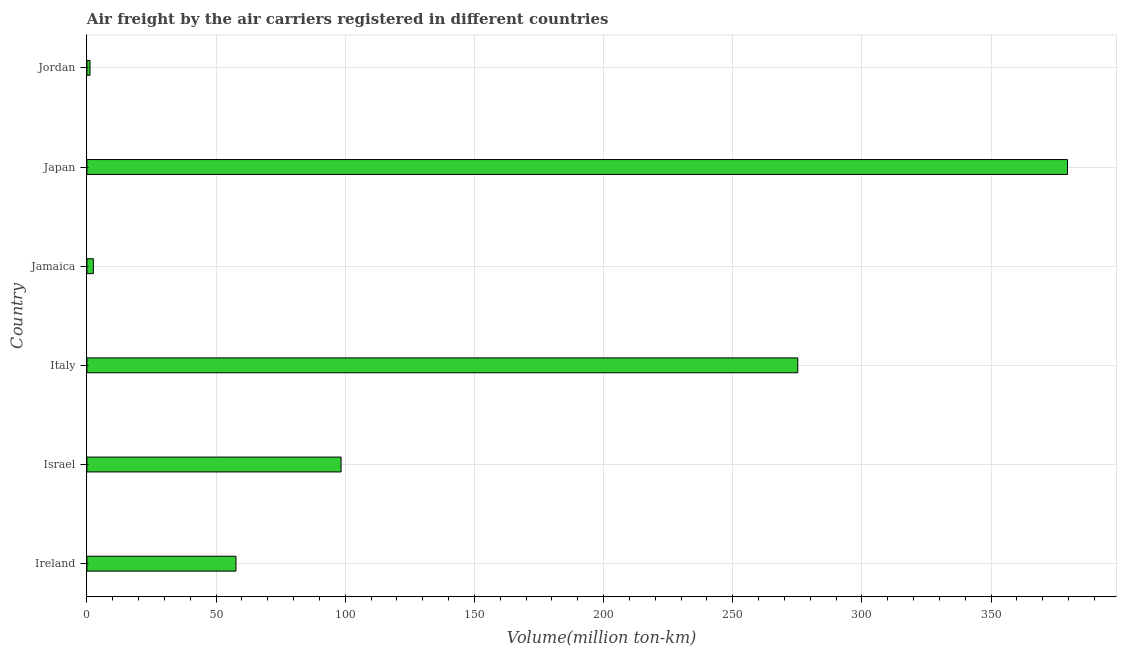Does the graph contain any zero values?
Provide a short and direct response. No. What is the title of the graph?
Ensure brevity in your answer.  Air freight by the air carriers registered in different countries. What is the label or title of the X-axis?
Provide a succinct answer. Volume(million ton-km). What is the air freight in Japan?
Offer a terse response. 379.6. Across all countries, what is the maximum air freight?
Give a very brief answer. 379.6. Across all countries, what is the minimum air freight?
Your answer should be compact. 1.2. In which country was the air freight maximum?
Your response must be concise. Japan. In which country was the air freight minimum?
Ensure brevity in your answer.  Jordan. What is the sum of the air freight?
Keep it short and to the point. 814.6. What is the difference between the air freight in Israel and Jordan?
Your answer should be compact. 97.2. What is the average air freight per country?
Your answer should be very brief. 135.77. What is the median air freight?
Give a very brief answer. 78.05. In how many countries, is the air freight greater than 80 million ton-km?
Offer a terse response. 3. What is the ratio of the air freight in Ireland to that in Israel?
Provide a short and direct response. 0.59. Is the air freight in Italy less than that in Jordan?
Give a very brief answer. No. What is the difference between the highest and the second highest air freight?
Provide a succinct answer. 104.4. What is the difference between the highest and the lowest air freight?
Your response must be concise. 378.4. In how many countries, is the air freight greater than the average air freight taken over all countries?
Your answer should be very brief. 2. How many countries are there in the graph?
Keep it short and to the point. 6. What is the difference between two consecutive major ticks on the X-axis?
Give a very brief answer. 50. What is the Volume(million ton-km) in Ireland?
Offer a very short reply. 57.7. What is the Volume(million ton-km) of Israel?
Your response must be concise. 98.4. What is the Volume(million ton-km) in Italy?
Provide a short and direct response. 275.2. What is the Volume(million ton-km) of Jamaica?
Keep it short and to the point. 2.5. What is the Volume(million ton-km) of Japan?
Your answer should be compact. 379.6. What is the Volume(million ton-km) in Jordan?
Provide a succinct answer. 1.2. What is the difference between the Volume(million ton-km) in Ireland and Israel?
Provide a succinct answer. -40.7. What is the difference between the Volume(million ton-km) in Ireland and Italy?
Offer a terse response. -217.5. What is the difference between the Volume(million ton-km) in Ireland and Jamaica?
Keep it short and to the point. 55.2. What is the difference between the Volume(million ton-km) in Ireland and Japan?
Offer a very short reply. -321.9. What is the difference between the Volume(million ton-km) in Ireland and Jordan?
Your answer should be very brief. 56.5. What is the difference between the Volume(million ton-km) in Israel and Italy?
Your answer should be compact. -176.8. What is the difference between the Volume(million ton-km) in Israel and Jamaica?
Offer a terse response. 95.9. What is the difference between the Volume(million ton-km) in Israel and Japan?
Provide a short and direct response. -281.2. What is the difference between the Volume(million ton-km) in Israel and Jordan?
Give a very brief answer. 97.2. What is the difference between the Volume(million ton-km) in Italy and Jamaica?
Your answer should be compact. 272.7. What is the difference between the Volume(million ton-km) in Italy and Japan?
Your answer should be compact. -104.4. What is the difference between the Volume(million ton-km) in Italy and Jordan?
Ensure brevity in your answer.  274. What is the difference between the Volume(million ton-km) in Jamaica and Japan?
Give a very brief answer. -377.1. What is the difference between the Volume(million ton-km) in Japan and Jordan?
Offer a terse response. 378.4. What is the ratio of the Volume(million ton-km) in Ireland to that in Israel?
Offer a very short reply. 0.59. What is the ratio of the Volume(million ton-km) in Ireland to that in Italy?
Your answer should be compact. 0.21. What is the ratio of the Volume(million ton-km) in Ireland to that in Jamaica?
Ensure brevity in your answer.  23.08. What is the ratio of the Volume(million ton-km) in Ireland to that in Japan?
Make the answer very short. 0.15. What is the ratio of the Volume(million ton-km) in Ireland to that in Jordan?
Your answer should be compact. 48.08. What is the ratio of the Volume(million ton-km) in Israel to that in Italy?
Provide a short and direct response. 0.36. What is the ratio of the Volume(million ton-km) in Israel to that in Jamaica?
Offer a terse response. 39.36. What is the ratio of the Volume(million ton-km) in Israel to that in Japan?
Your answer should be very brief. 0.26. What is the ratio of the Volume(million ton-km) in Israel to that in Jordan?
Give a very brief answer. 82. What is the ratio of the Volume(million ton-km) in Italy to that in Jamaica?
Your response must be concise. 110.08. What is the ratio of the Volume(million ton-km) in Italy to that in Japan?
Provide a short and direct response. 0.72. What is the ratio of the Volume(million ton-km) in Italy to that in Jordan?
Keep it short and to the point. 229.33. What is the ratio of the Volume(million ton-km) in Jamaica to that in Japan?
Ensure brevity in your answer.  0.01. What is the ratio of the Volume(million ton-km) in Jamaica to that in Jordan?
Keep it short and to the point. 2.08. What is the ratio of the Volume(million ton-km) in Japan to that in Jordan?
Ensure brevity in your answer.  316.33. 